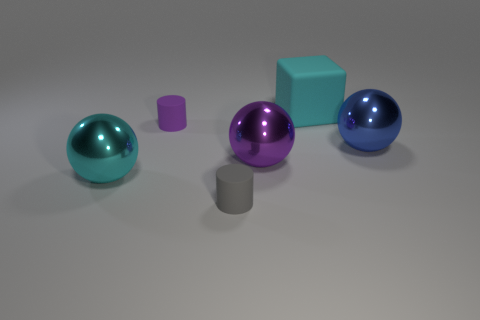Do the big object that is behind the small purple thing and the blue object have the same shape?
Offer a terse response. No. There is a gray thing that is made of the same material as the cyan cube; what size is it?
Offer a very short reply. Small. There is a cyan sphere that is left of the tiny rubber object in front of the small cylinder that is behind the gray thing; what is its material?
Ensure brevity in your answer.  Metal. Are there fewer purple balls than shiny objects?
Provide a short and direct response. Yes. Do the blue thing and the purple cylinder have the same material?
Your answer should be very brief. No. What shape is the object that is the same color as the large matte block?
Keep it short and to the point. Sphere. Is the color of the large object on the left side of the small purple rubber object the same as the big cube?
Your answer should be compact. Yes. There is a large cyan ball that is in front of the cyan matte object; how many cyan metallic objects are behind it?
Make the answer very short. 0. What is the color of the rubber object that is the same size as the blue metal ball?
Make the answer very short. Cyan. There is a big cyan object that is behind the cyan metal thing; what is its material?
Your answer should be compact. Rubber. 